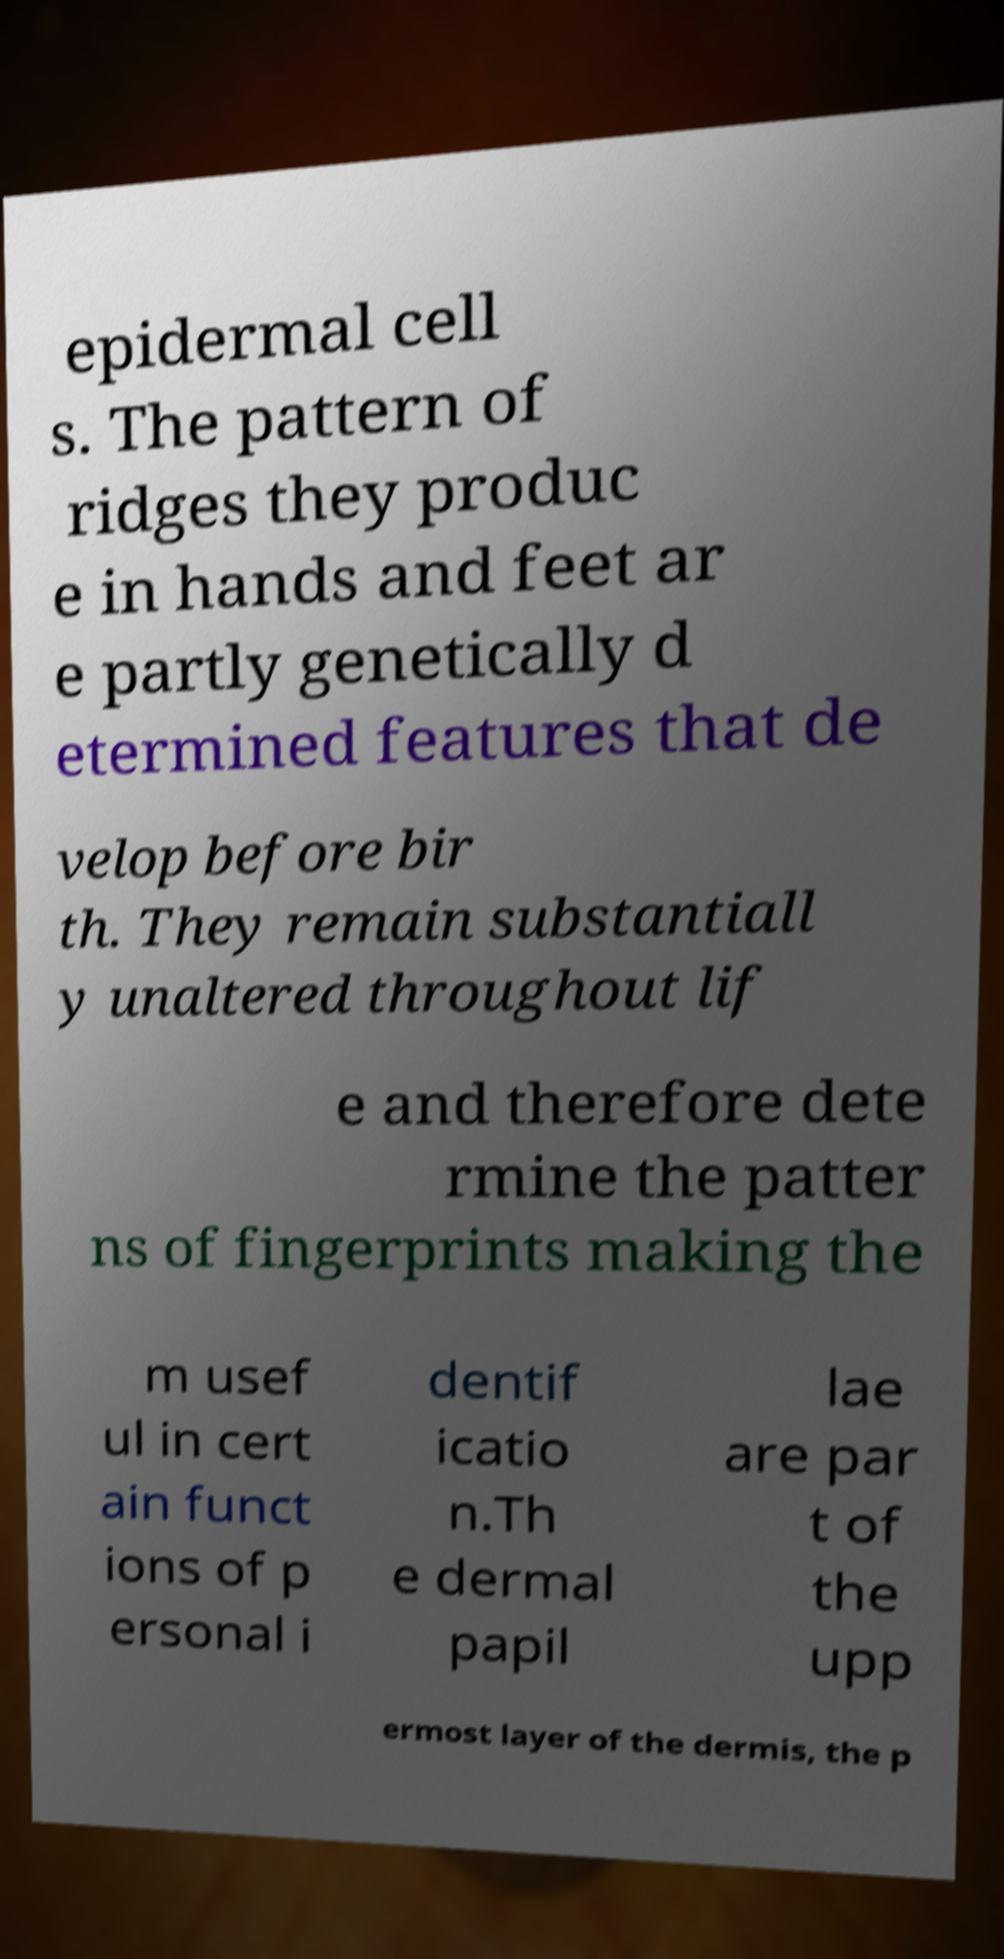Please read and relay the text visible in this image. What does it say? epidermal cell s. The pattern of ridges they produc e in hands and feet ar e partly genetically d etermined features that de velop before bir th. They remain substantiall y unaltered throughout lif e and therefore dete rmine the patter ns of fingerprints making the m usef ul in cert ain funct ions of p ersonal i dentif icatio n.Th e dermal papil lae are par t of the upp ermost layer of the dermis, the p 